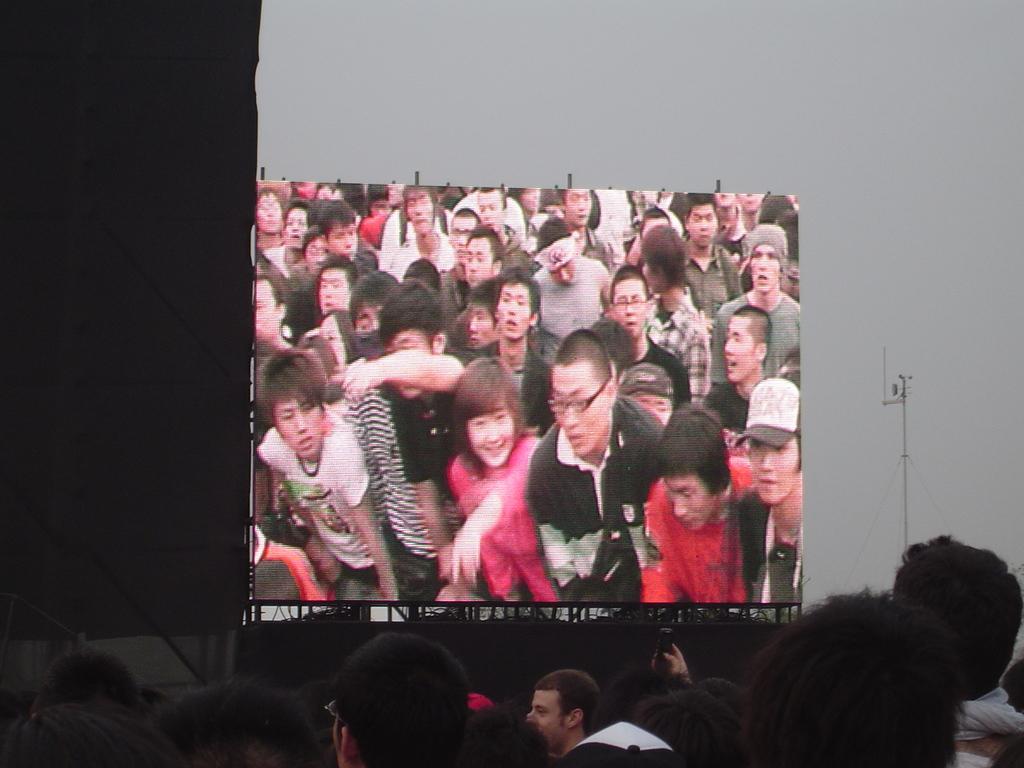Could you give a brief overview of what you see in this image? In this picture there is a screen in the middle of the image, In the screen there are group of people standing. On the left side of the image there is a black color cloth on the pole. In the foreground there are group of people. On the right side of the image there is a pole. At the top there is sky. 